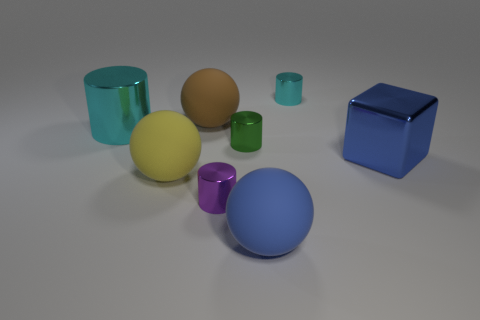Subtract all large metal cylinders. How many cylinders are left? 3 Subtract all red blocks. How many cyan cylinders are left? 2 Subtract all green cylinders. How many cylinders are left? 3 Add 1 big red metal cylinders. How many objects exist? 9 Subtract 3 cylinders. How many cylinders are left? 1 Subtract all brown spheres. Subtract all gray blocks. How many spheres are left? 2 Subtract 0 green balls. How many objects are left? 8 Subtract all cubes. How many objects are left? 7 Subtract all large gray rubber spheres. Subtract all blue objects. How many objects are left? 6 Add 2 tiny cylinders. How many tiny cylinders are left? 5 